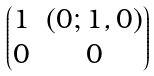<formula> <loc_0><loc_0><loc_500><loc_500>\begin{pmatrix} 1 & ( 0 ; 1 , 0 ) \\ 0 & 0 \end{pmatrix}</formula> 